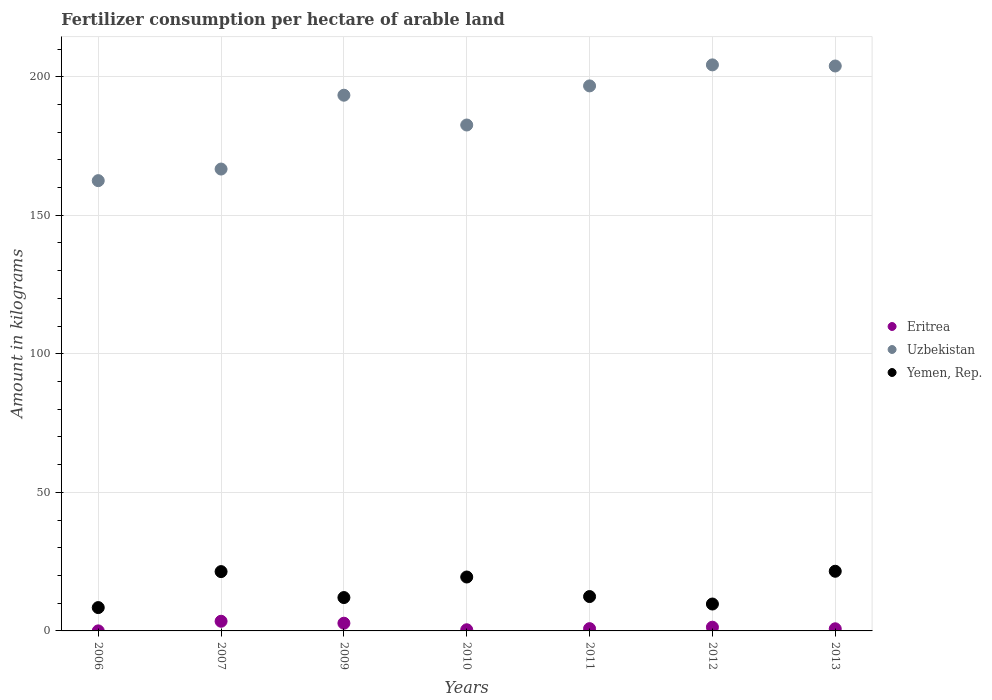Is the number of dotlines equal to the number of legend labels?
Provide a succinct answer. Yes. What is the amount of fertilizer consumption in Yemen, Rep. in 2010?
Keep it short and to the point. 19.46. Across all years, what is the maximum amount of fertilizer consumption in Eritrea?
Keep it short and to the point. 3.49. Across all years, what is the minimum amount of fertilizer consumption in Uzbekistan?
Offer a terse response. 162.5. What is the total amount of fertilizer consumption in Yemen, Rep. in the graph?
Ensure brevity in your answer.  104.98. What is the difference between the amount of fertilizer consumption in Yemen, Rep. in 2009 and that in 2010?
Keep it short and to the point. -7.42. What is the difference between the amount of fertilizer consumption in Uzbekistan in 2012 and the amount of fertilizer consumption in Yemen, Rep. in 2010?
Offer a terse response. 184.82. What is the average amount of fertilizer consumption in Yemen, Rep. per year?
Make the answer very short. 15. In the year 2007, what is the difference between the amount of fertilizer consumption in Eritrea and amount of fertilizer consumption in Uzbekistan?
Your answer should be very brief. -163.2. What is the ratio of the amount of fertilizer consumption in Eritrea in 2009 to that in 2013?
Your answer should be compact. 3.62. Is the amount of fertilizer consumption in Uzbekistan in 2009 less than that in 2012?
Ensure brevity in your answer.  Yes. What is the difference between the highest and the second highest amount of fertilizer consumption in Yemen, Rep.?
Provide a short and direct response. 0.13. What is the difference between the highest and the lowest amount of fertilizer consumption in Uzbekistan?
Provide a succinct answer. 41.78. Is the sum of the amount of fertilizer consumption in Yemen, Rep. in 2009 and 2012 greater than the maximum amount of fertilizer consumption in Eritrea across all years?
Ensure brevity in your answer.  Yes. Is it the case that in every year, the sum of the amount of fertilizer consumption in Uzbekistan and amount of fertilizer consumption in Eritrea  is greater than the amount of fertilizer consumption in Yemen, Rep.?
Offer a very short reply. Yes. How many dotlines are there?
Provide a succinct answer. 3. How many years are there in the graph?
Ensure brevity in your answer.  7. Does the graph contain grids?
Offer a very short reply. Yes. Where does the legend appear in the graph?
Your response must be concise. Center right. How many legend labels are there?
Offer a very short reply. 3. What is the title of the graph?
Offer a terse response. Fertilizer consumption per hectare of arable land. What is the label or title of the X-axis?
Your response must be concise. Years. What is the label or title of the Y-axis?
Provide a succinct answer. Amount in kilograms. What is the Amount in kilograms in Eritrea in 2006?
Make the answer very short. 0.02. What is the Amount in kilograms in Uzbekistan in 2006?
Keep it short and to the point. 162.5. What is the Amount in kilograms in Yemen, Rep. in 2006?
Your answer should be compact. 8.42. What is the Amount in kilograms in Eritrea in 2007?
Ensure brevity in your answer.  3.49. What is the Amount in kilograms in Uzbekistan in 2007?
Offer a terse response. 166.69. What is the Amount in kilograms of Yemen, Rep. in 2007?
Your answer should be very brief. 21.41. What is the Amount in kilograms of Eritrea in 2009?
Your response must be concise. 2.78. What is the Amount in kilograms in Uzbekistan in 2009?
Offer a very short reply. 193.34. What is the Amount in kilograms of Yemen, Rep. in 2009?
Offer a very short reply. 12.04. What is the Amount in kilograms in Eritrea in 2010?
Keep it short and to the point. 0.42. What is the Amount in kilograms in Uzbekistan in 2010?
Ensure brevity in your answer.  182.58. What is the Amount in kilograms in Yemen, Rep. in 2010?
Your answer should be very brief. 19.46. What is the Amount in kilograms in Eritrea in 2011?
Provide a succinct answer. 0.82. What is the Amount in kilograms of Uzbekistan in 2011?
Provide a short and direct response. 196.7. What is the Amount in kilograms in Yemen, Rep. in 2011?
Offer a terse response. 12.4. What is the Amount in kilograms of Eritrea in 2012?
Offer a terse response. 1.34. What is the Amount in kilograms in Uzbekistan in 2012?
Offer a terse response. 204.28. What is the Amount in kilograms of Yemen, Rep. in 2012?
Your answer should be very brief. 9.71. What is the Amount in kilograms of Eritrea in 2013?
Keep it short and to the point. 0.77. What is the Amount in kilograms of Uzbekistan in 2013?
Keep it short and to the point. 203.88. What is the Amount in kilograms in Yemen, Rep. in 2013?
Keep it short and to the point. 21.53. Across all years, what is the maximum Amount in kilograms in Eritrea?
Give a very brief answer. 3.49. Across all years, what is the maximum Amount in kilograms in Uzbekistan?
Your answer should be very brief. 204.28. Across all years, what is the maximum Amount in kilograms in Yemen, Rep.?
Give a very brief answer. 21.53. Across all years, what is the minimum Amount in kilograms in Eritrea?
Your answer should be very brief. 0.02. Across all years, what is the minimum Amount in kilograms in Uzbekistan?
Ensure brevity in your answer.  162.5. Across all years, what is the minimum Amount in kilograms in Yemen, Rep.?
Your answer should be very brief. 8.42. What is the total Amount in kilograms of Eritrea in the graph?
Offer a very short reply. 9.64. What is the total Amount in kilograms in Uzbekistan in the graph?
Offer a very short reply. 1309.96. What is the total Amount in kilograms in Yemen, Rep. in the graph?
Offer a very short reply. 104.98. What is the difference between the Amount in kilograms of Eritrea in 2006 and that in 2007?
Offer a very short reply. -3.47. What is the difference between the Amount in kilograms of Uzbekistan in 2006 and that in 2007?
Ensure brevity in your answer.  -4.19. What is the difference between the Amount in kilograms of Yemen, Rep. in 2006 and that in 2007?
Make the answer very short. -12.98. What is the difference between the Amount in kilograms in Eritrea in 2006 and that in 2009?
Provide a succinct answer. -2.77. What is the difference between the Amount in kilograms in Uzbekistan in 2006 and that in 2009?
Offer a very short reply. -30.84. What is the difference between the Amount in kilograms of Yemen, Rep. in 2006 and that in 2009?
Make the answer very short. -3.62. What is the difference between the Amount in kilograms in Eritrea in 2006 and that in 2010?
Provide a succinct answer. -0.4. What is the difference between the Amount in kilograms in Uzbekistan in 2006 and that in 2010?
Provide a short and direct response. -20.08. What is the difference between the Amount in kilograms in Yemen, Rep. in 2006 and that in 2010?
Your response must be concise. -11.03. What is the difference between the Amount in kilograms in Eritrea in 2006 and that in 2011?
Offer a terse response. -0.81. What is the difference between the Amount in kilograms in Uzbekistan in 2006 and that in 2011?
Ensure brevity in your answer.  -34.2. What is the difference between the Amount in kilograms of Yemen, Rep. in 2006 and that in 2011?
Provide a short and direct response. -3.98. What is the difference between the Amount in kilograms of Eritrea in 2006 and that in 2012?
Provide a short and direct response. -1.33. What is the difference between the Amount in kilograms in Uzbekistan in 2006 and that in 2012?
Give a very brief answer. -41.78. What is the difference between the Amount in kilograms in Yemen, Rep. in 2006 and that in 2012?
Ensure brevity in your answer.  -1.29. What is the difference between the Amount in kilograms in Eritrea in 2006 and that in 2013?
Keep it short and to the point. -0.75. What is the difference between the Amount in kilograms in Uzbekistan in 2006 and that in 2013?
Offer a very short reply. -41.38. What is the difference between the Amount in kilograms in Yemen, Rep. in 2006 and that in 2013?
Provide a short and direct response. -13.11. What is the difference between the Amount in kilograms in Eritrea in 2007 and that in 2009?
Your response must be concise. 0.71. What is the difference between the Amount in kilograms of Uzbekistan in 2007 and that in 2009?
Your answer should be very brief. -26.65. What is the difference between the Amount in kilograms in Yemen, Rep. in 2007 and that in 2009?
Provide a short and direct response. 9.37. What is the difference between the Amount in kilograms of Eritrea in 2007 and that in 2010?
Keep it short and to the point. 3.07. What is the difference between the Amount in kilograms of Uzbekistan in 2007 and that in 2010?
Provide a succinct answer. -15.89. What is the difference between the Amount in kilograms in Yemen, Rep. in 2007 and that in 2010?
Ensure brevity in your answer.  1.95. What is the difference between the Amount in kilograms in Eritrea in 2007 and that in 2011?
Offer a terse response. 2.67. What is the difference between the Amount in kilograms of Uzbekistan in 2007 and that in 2011?
Provide a succinct answer. -30.01. What is the difference between the Amount in kilograms in Yemen, Rep. in 2007 and that in 2011?
Give a very brief answer. 9. What is the difference between the Amount in kilograms of Eritrea in 2007 and that in 2012?
Your answer should be very brief. 2.15. What is the difference between the Amount in kilograms of Uzbekistan in 2007 and that in 2012?
Your answer should be very brief. -37.6. What is the difference between the Amount in kilograms in Yemen, Rep. in 2007 and that in 2012?
Provide a short and direct response. 11.7. What is the difference between the Amount in kilograms of Eritrea in 2007 and that in 2013?
Keep it short and to the point. 2.72. What is the difference between the Amount in kilograms of Uzbekistan in 2007 and that in 2013?
Make the answer very short. -37.2. What is the difference between the Amount in kilograms of Yemen, Rep. in 2007 and that in 2013?
Provide a succinct answer. -0.13. What is the difference between the Amount in kilograms in Eritrea in 2009 and that in 2010?
Provide a short and direct response. 2.37. What is the difference between the Amount in kilograms in Uzbekistan in 2009 and that in 2010?
Offer a very short reply. 10.75. What is the difference between the Amount in kilograms in Yemen, Rep. in 2009 and that in 2010?
Provide a succinct answer. -7.42. What is the difference between the Amount in kilograms in Eritrea in 2009 and that in 2011?
Offer a terse response. 1.96. What is the difference between the Amount in kilograms in Uzbekistan in 2009 and that in 2011?
Keep it short and to the point. -3.36. What is the difference between the Amount in kilograms in Yemen, Rep. in 2009 and that in 2011?
Offer a terse response. -0.36. What is the difference between the Amount in kilograms of Eritrea in 2009 and that in 2012?
Your response must be concise. 1.44. What is the difference between the Amount in kilograms in Uzbekistan in 2009 and that in 2012?
Your answer should be very brief. -10.95. What is the difference between the Amount in kilograms of Yemen, Rep. in 2009 and that in 2012?
Your answer should be compact. 2.33. What is the difference between the Amount in kilograms in Eritrea in 2009 and that in 2013?
Provide a short and direct response. 2.01. What is the difference between the Amount in kilograms in Uzbekistan in 2009 and that in 2013?
Your answer should be compact. -10.55. What is the difference between the Amount in kilograms in Yemen, Rep. in 2009 and that in 2013?
Ensure brevity in your answer.  -9.49. What is the difference between the Amount in kilograms in Eritrea in 2010 and that in 2011?
Keep it short and to the point. -0.4. What is the difference between the Amount in kilograms of Uzbekistan in 2010 and that in 2011?
Ensure brevity in your answer.  -14.11. What is the difference between the Amount in kilograms in Yemen, Rep. in 2010 and that in 2011?
Offer a very short reply. 7.05. What is the difference between the Amount in kilograms of Eritrea in 2010 and that in 2012?
Your response must be concise. -0.93. What is the difference between the Amount in kilograms of Uzbekistan in 2010 and that in 2012?
Your answer should be compact. -21.7. What is the difference between the Amount in kilograms of Yemen, Rep. in 2010 and that in 2012?
Offer a terse response. 9.75. What is the difference between the Amount in kilograms of Eritrea in 2010 and that in 2013?
Offer a very short reply. -0.35. What is the difference between the Amount in kilograms of Uzbekistan in 2010 and that in 2013?
Keep it short and to the point. -21.3. What is the difference between the Amount in kilograms of Yemen, Rep. in 2010 and that in 2013?
Keep it short and to the point. -2.08. What is the difference between the Amount in kilograms of Eritrea in 2011 and that in 2012?
Provide a short and direct response. -0.52. What is the difference between the Amount in kilograms of Uzbekistan in 2011 and that in 2012?
Ensure brevity in your answer.  -7.59. What is the difference between the Amount in kilograms of Yemen, Rep. in 2011 and that in 2012?
Provide a succinct answer. 2.69. What is the difference between the Amount in kilograms in Eritrea in 2011 and that in 2013?
Provide a succinct answer. 0.05. What is the difference between the Amount in kilograms in Uzbekistan in 2011 and that in 2013?
Offer a terse response. -7.19. What is the difference between the Amount in kilograms of Yemen, Rep. in 2011 and that in 2013?
Offer a terse response. -9.13. What is the difference between the Amount in kilograms in Eritrea in 2012 and that in 2013?
Ensure brevity in your answer.  0.57. What is the difference between the Amount in kilograms in Uzbekistan in 2012 and that in 2013?
Ensure brevity in your answer.  0.4. What is the difference between the Amount in kilograms of Yemen, Rep. in 2012 and that in 2013?
Offer a terse response. -11.82. What is the difference between the Amount in kilograms of Eritrea in 2006 and the Amount in kilograms of Uzbekistan in 2007?
Ensure brevity in your answer.  -166.67. What is the difference between the Amount in kilograms in Eritrea in 2006 and the Amount in kilograms in Yemen, Rep. in 2007?
Offer a terse response. -21.39. What is the difference between the Amount in kilograms in Uzbekistan in 2006 and the Amount in kilograms in Yemen, Rep. in 2007?
Provide a succinct answer. 141.09. What is the difference between the Amount in kilograms of Eritrea in 2006 and the Amount in kilograms of Uzbekistan in 2009?
Provide a short and direct response. -193.32. What is the difference between the Amount in kilograms in Eritrea in 2006 and the Amount in kilograms in Yemen, Rep. in 2009?
Offer a terse response. -12.02. What is the difference between the Amount in kilograms in Uzbekistan in 2006 and the Amount in kilograms in Yemen, Rep. in 2009?
Offer a terse response. 150.46. What is the difference between the Amount in kilograms in Eritrea in 2006 and the Amount in kilograms in Uzbekistan in 2010?
Give a very brief answer. -182.56. What is the difference between the Amount in kilograms of Eritrea in 2006 and the Amount in kilograms of Yemen, Rep. in 2010?
Ensure brevity in your answer.  -19.44. What is the difference between the Amount in kilograms of Uzbekistan in 2006 and the Amount in kilograms of Yemen, Rep. in 2010?
Make the answer very short. 143.04. What is the difference between the Amount in kilograms of Eritrea in 2006 and the Amount in kilograms of Uzbekistan in 2011?
Give a very brief answer. -196.68. What is the difference between the Amount in kilograms of Eritrea in 2006 and the Amount in kilograms of Yemen, Rep. in 2011?
Offer a very short reply. -12.39. What is the difference between the Amount in kilograms in Uzbekistan in 2006 and the Amount in kilograms in Yemen, Rep. in 2011?
Your answer should be compact. 150.1. What is the difference between the Amount in kilograms in Eritrea in 2006 and the Amount in kilograms in Uzbekistan in 2012?
Give a very brief answer. -204.27. What is the difference between the Amount in kilograms of Eritrea in 2006 and the Amount in kilograms of Yemen, Rep. in 2012?
Your response must be concise. -9.69. What is the difference between the Amount in kilograms in Uzbekistan in 2006 and the Amount in kilograms in Yemen, Rep. in 2012?
Keep it short and to the point. 152.79. What is the difference between the Amount in kilograms in Eritrea in 2006 and the Amount in kilograms in Uzbekistan in 2013?
Provide a short and direct response. -203.87. What is the difference between the Amount in kilograms in Eritrea in 2006 and the Amount in kilograms in Yemen, Rep. in 2013?
Keep it short and to the point. -21.52. What is the difference between the Amount in kilograms of Uzbekistan in 2006 and the Amount in kilograms of Yemen, Rep. in 2013?
Keep it short and to the point. 140.97. What is the difference between the Amount in kilograms of Eritrea in 2007 and the Amount in kilograms of Uzbekistan in 2009?
Your answer should be compact. -189.85. What is the difference between the Amount in kilograms in Eritrea in 2007 and the Amount in kilograms in Yemen, Rep. in 2009?
Ensure brevity in your answer.  -8.55. What is the difference between the Amount in kilograms in Uzbekistan in 2007 and the Amount in kilograms in Yemen, Rep. in 2009?
Ensure brevity in your answer.  154.65. What is the difference between the Amount in kilograms in Eritrea in 2007 and the Amount in kilograms in Uzbekistan in 2010?
Provide a succinct answer. -179.09. What is the difference between the Amount in kilograms of Eritrea in 2007 and the Amount in kilograms of Yemen, Rep. in 2010?
Your answer should be compact. -15.97. What is the difference between the Amount in kilograms of Uzbekistan in 2007 and the Amount in kilograms of Yemen, Rep. in 2010?
Provide a succinct answer. 147.23. What is the difference between the Amount in kilograms in Eritrea in 2007 and the Amount in kilograms in Uzbekistan in 2011?
Your response must be concise. -193.21. What is the difference between the Amount in kilograms in Eritrea in 2007 and the Amount in kilograms in Yemen, Rep. in 2011?
Provide a short and direct response. -8.91. What is the difference between the Amount in kilograms in Uzbekistan in 2007 and the Amount in kilograms in Yemen, Rep. in 2011?
Provide a succinct answer. 154.28. What is the difference between the Amount in kilograms of Eritrea in 2007 and the Amount in kilograms of Uzbekistan in 2012?
Make the answer very short. -200.79. What is the difference between the Amount in kilograms of Eritrea in 2007 and the Amount in kilograms of Yemen, Rep. in 2012?
Ensure brevity in your answer.  -6.22. What is the difference between the Amount in kilograms of Uzbekistan in 2007 and the Amount in kilograms of Yemen, Rep. in 2012?
Give a very brief answer. 156.98. What is the difference between the Amount in kilograms in Eritrea in 2007 and the Amount in kilograms in Uzbekistan in 2013?
Offer a very short reply. -200.39. What is the difference between the Amount in kilograms of Eritrea in 2007 and the Amount in kilograms of Yemen, Rep. in 2013?
Your answer should be very brief. -18.04. What is the difference between the Amount in kilograms in Uzbekistan in 2007 and the Amount in kilograms in Yemen, Rep. in 2013?
Provide a succinct answer. 145.15. What is the difference between the Amount in kilograms of Eritrea in 2009 and the Amount in kilograms of Uzbekistan in 2010?
Provide a succinct answer. -179.8. What is the difference between the Amount in kilograms of Eritrea in 2009 and the Amount in kilograms of Yemen, Rep. in 2010?
Your answer should be compact. -16.68. What is the difference between the Amount in kilograms of Uzbekistan in 2009 and the Amount in kilograms of Yemen, Rep. in 2010?
Offer a terse response. 173.88. What is the difference between the Amount in kilograms in Eritrea in 2009 and the Amount in kilograms in Uzbekistan in 2011?
Ensure brevity in your answer.  -193.91. What is the difference between the Amount in kilograms in Eritrea in 2009 and the Amount in kilograms in Yemen, Rep. in 2011?
Offer a very short reply. -9.62. What is the difference between the Amount in kilograms of Uzbekistan in 2009 and the Amount in kilograms of Yemen, Rep. in 2011?
Ensure brevity in your answer.  180.93. What is the difference between the Amount in kilograms of Eritrea in 2009 and the Amount in kilograms of Uzbekistan in 2012?
Keep it short and to the point. -201.5. What is the difference between the Amount in kilograms in Eritrea in 2009 and the Amount in kilograms in Yemen, Rep. in 2012?
Provide a short and direct response. -6.93. What is the difference between the Amount in kilograms in Uzbekistan in 2009 and the Amount in kilograms in Yemen, Rep. in 2012?
Make the answer very short. 183.63. What is the difference between the Amount in kilograms in Eritrea in 2009 and the Amount in kilograms in Uzbekistan in 2013?
Give a very brief answer. -201.1. What is the difference between the Amount in kilograms of Eritrea in 2009 and the Amount in kilograms of Yemen, Rep. in 2013?
Ensure brevity in your answer.  -18.75. What is the difference between the Amount in kilograms of Uzbekistan in 2009 and the Amount in kilograms of Yemen, Rep. in 2013?
Keep it short and to the point. 171.8. What is the difference between the Amount in kilograms of Eritrea in 2010 and the Amount in kilograms of Uzbekistan in 2011?
Provide a succinct answer. -196.28. What is the difference between the Amount in kilograms in Eritrea in 2010 and the Amount in kilograms in Yemen, Rep. in 2011?
Provide a short and direct response. -11.99. What is the difference between the Amount in kilograms in Uzbekistan in 2010 and the Amount in kilograms in Yemen, Rep. in 2011?
Provide a succinct answer. 170.18. What is the difference between the Amount in kilograms of Eritrea in 2010 and the Amount in kilograms of Uzbekistan in 2012?
Ensure brevity in your answer.  -203.86. What is the difference between the Amount in kilograms in Eritrea in 2010 and the Amount in kilograms in Yemen, Rep. in 2012?
Offer a very short reply. -9.29. What is the difference between the Amount in kilograms in Uzbekistan in 2010 and the Amount in kilograms in Yemen, Rep. in 2012?
Offer a terse response. 172.87. What is the difference between the Amount in kilograms of Eritrea in 2010 and the Amount in kilograms of Uzbekistan in 2013?
Your answer should be very brief. -203.46. What is the difference between the Amount in kilograms in Eritrea in 2010 and the Amount in kilograms in Yemen, Rep. in 2013?
Offer a very short reply. -21.12. What is the difference between the Amount in kilograms in Uzbekistan in 2010 and the Amount in kilograms in Yemen, Rep. in 2013?
Provide a succinct answer. 161.05. What is the difference between the Amount in kilograms in Eritrea in 2011 and the Amount in kilograms in Uzbekistan in 2012?
Give a very brief answer. -203.46. What is the difference between the Amount in kilograms of Eritrea in 2011 and the Amount in kilograms of Yemen, Rep. in 2012?
Offer a very short reply. -8.89. What is the difference between the Amount in kilograms in Uzbekistan in 2011 and the Amount in kilograms in Yemen, Rep. in 2012?
Keep it short and to the point. 186.99. What is the difference between the Amount in kilograms of Eritrea in 2011 and the Amount in kilograms of Uzbekistan in 2013?
Provide a succinct answer. -203.06. What is the difference between the Amount in kilograms in Eritrea in 2011 and the Amount in kilograms in Yemen, Rep. in 2013?
Offer a very short reply. -20.71. What is the difference between the Amount in kilograms in Uzbekistan in 2011 and the Amount in kilograms in Yemen, Rep. in 2013?
Your response must be concise. 175.16. What is the difference between the Amount in kilograms of Eritrea in 2012 and the Amount in kilograms of Uzbekistan in 2013?
Give a very brief answer. -202.54. What is the difference between the Amount in kilograms in Eritrea in 2012 and the Amount in kilograms in Yemen, Rep. in 2013?
Offer a very short reply. -20.19. What is the difference between the Amount in kilograms of Uzbekistan in 2012 and the Amount in kilograms of Yemen, Rep. in 2013?
Offer a very short reply. 182.75. What is the average Amount in kilograms of Eritrea per year?
Make the answer very short. 1.38. What is the average Amount in kilograms in Uzbekistan per year?
Keep it short and to the point. 187.14. What is the average Amount in kilograms of Yemen, Rep. per year?
Make the answer very short. 15. In the year 2006, what is the difference between the Amount in kilograms of Eritrea and Amount in kilograms of Uzbekistan?
Provide a short and direct response. -162.48. In the year 2006, what is the difference between the Amount in kilograms of Eritrea and Amount in kilograms of Yemen, Rep.?
Your answer should be compact. -8.41. In the year 2006, what is the difference between the Amount in kilograms in Uzbekistan and Amount in kilograms in Yemen, Rep.?
Provide a succinct answer. 154.08. In the year 2007, what is the difference between the Amount in kilograms of Eritrea and Amount in kilograms of Uzbekistan?
Offer a terse response. -163.2. In the year 2007, what is the difference between the Amount in kilograms of Eritrea and Amount in kilograms of Yemen, Rep.?
Give a very brief answer. -17.92. In the year 2007, what is the difference between the Amount in kilograms of Uzbekistan and Amount in kilograms of Yemen, Rep.?
Provide a succinct answer. 145.28. In the year 2009, what is the difference between the Amount in kilograms in Eritrea and Amount in kilograms in Uzbekistan?
Keep it short and to the point. -190.55. In the year 2009, what is the difference between the Amount in kilograms in Eritrea and Amount in kilograms in Yemen, Rep.?
Give a very brief answer. -9.26. In the year 2009, what is the difference between the Amount in kilograms of Uzbekistan and Amount in kilograms of Yemen, Rep.?
Provide a short and direct response. 181.29. In the year 2010, what is the difference between the Amount in kilograms of Eritrea and Amount in kilograms of Uzbekistan?
Offer a very short reply. -182.16. In the year 2010, what is the difference between the Amount in kilograms in Eritrea and Amount in kilograms in Yemen, Rep.?
Offer a very short reply. -19.04. In the year 2010, what is the difference between the Amount in kilograms of Uzbekistan and Amount in kilograms of Yemen, Rep.?
Your answer should be compact. 163.12. In the year 2011, what is the difference between the Amount in kilograms in Eritrea and Amount in kilograms in Uzbekistan?
Give a very brief answer. -195.87. In the year 2011, what is the difference between the Amount in kilograms of Eritrea and Amount in kilograms of Yemen, Rep.?
Your response must be concise. -11.58. In the year 2011, what is the difference between the Amount in kilograms of Uzbekistan and Amount in kilograms of Yemen, Rep.?
Your answer should be very brief. 184.29. In the year 2012, what is the difference between the Amount in kilograms of Eritrea and Amount in kilograms of Uzbekistan?
Your response must be concise. -202.94. In the year 2012, what is the difference between the Amount in kilograms in Eritrea and Amount in kilograms in Yemen, Rep.?
Offer a very short reply. -8.37. In the year 2012, what is the difference between the Amount in kilograms in Uzbekistan and Amount in kilograms in Yemen, Rep.?
Provide a succinct answer. 194.57. In the year 2013, what is the difference between the Amount in kilograms in Eritrea and Amount in kilograms in Uzbekistan?
Offer a very short reply. -203.11. In the year 2013, what is the difference between the Amount in kilograms in Eritrea and Amount in kilograms in Yemen, Rep.?
Provide a succinct answer. -20.76. In the year 2013, what is the difference between the Amount in kilograms of Uzbekistan and Amount in kilograms of Yemen, Rep.?
Ensure brevity in your answer.  182.35. What is the ratio of the Amount in kilograms in Eritrea in 2006 to that in 2007?
Make the answer very short. 0. What is the ratio of the Amount in kilograms of Uzbekistan in 2006 to that in 2007?
Provide a short and direct response. 0.97. What is the ratio of the Amount in kilograms of Yemen, Rep. in 2006 to that in 2007?
Offer a very short reply. 0.39. What is the ratio of the Amount in kilograms in Eritrea in 2006 to that in 2009?
Offer a terse response. 0.01. What is the ratio of the Amount in kilograms in Uzbekistan in 2006 to that in 2009?
Make the answer very short. 0.84. What is the ratio of the Amount in kilograms in Yemen, Rep. in 2006 to that in 2009?
Your answer should be compact. 0.7. What is the ratio of the Amount in kilograms of Eritrea in 2006 to that in 2010?
Offer a terse response. 0.04. What is the ratio of the Amount in kilograms of Uzbekistan in 2006 to that in 2010?
Offer a very short reply. 0.89. What is the ratio of the Amount in kilograms of Yemen, Rep. in 2006 to that in 2010?
Make the answer very short. 0.43. What is the ratio of the Amount in kilograms in Uzbekistan in 2006 to that in 2011?
Offer a very short reply. 0.83. What is the ratio of the Amount in kilograms in Yemen, Rep. in 2006 to that in 2011?
Give a very brief answer. 0.68. What is the ratio of the Amount in kilograms of Eritrea in 2006 to that in 2012?
Offer a terse response. 0.01. What is the ratio of the Amount in kilograms of Uzbekistan in 2006 to that in 2012?
Give a very brief answer. 0.8. What is the ratio of the Amount in kilograms in Yemen, Rep. in 2006 to that in 2012?
Provide a succinct answer. 0.87. What is the ratio of the Amount in kilograms of Eritrea in 2006 to that in 2013?
Give a very brief answer. 0.02. What is the ratio of the Amount in kilograms in Uzbekistan in 2006 to that in 2013?
Your answer should be compact. 0.8. What is the ratio of the Amount in kilograms of Yemen, Rep. in 2006 to that in 2013?
Your answer should be compact. 0.39. What is the ratio of the Amount in kilograms in Eritrea in 2007 to that in 2009?
Your answer should be compact. 1.25. What is the ratio of the Amount in kilograms of Uzbekistan in 2007 to that in 2009?
Provide a succinct answer. 0.86. What is the ratio of the Amount in kilograms of Yemen, Rep. in 2007 to that in 2009?
Offer a very short reply. 1.78. What is the ratio of the Amount in kilograms in Eritrea in 2007 to that in 2010?
Your answer should be very brief. 8.36. What is the ratio of the Amount in kilograms in Uzbekistan in 2007 to that in 2010?
Provide a short and direct response. 0.91. What is the ratio of the Amount in kilograms of Yemen, Rep. in 2007 to that in 2010?
Give a very brief answer. 1.1. What is the ratio of the Amount in kilograms of Eritrea in 2007 to that in 2011?
Keep it short and to the point. 4.25. What is the ratio of the Amount in kilograms of Uzbekistan in 2007 to that in 2011?
Your answer should be compact. 0.85. What is the ratio of the Amount in kilograms of Yemen, Rep. in 2007 to that in 2011?
Offer a very short reply. 1.73. What is the ratio of the Amount in kilograms of Eritrea in 2007 to that in 2012?
Your response must be concise. 2.6. What is the ratio of the Amount in kilograms of Uzbekistan in 2007 to that in 2012?
Ensure brevity in your answer.  0.82. What is the ratio of the Amount in kilograms of Yemen, Rep. in 2007 to that in 2012?
Your answer should be compact. 2.2. What is the ratio of the Amount in kilograms of Eritrea in 2007 to that in 2013?
Provide a short and direct response. 4.53. What is the ratio of the Amount in kilograms of Uzbekistan in 2007 to that in 2013?
Provide a succinct answer. 0.82. What is the ratio of the Amount in kilograms in Yemen, Rep. in 2007 to that in 2013?
Your answer should be very brief. 0.99. What is the ratio of the Amount in kilograms in Eritrea in 2009 to that in 2010?
Give a very brief answer. 6.67. What is the ratio of the Amount in kilograms of Uzbekistan in 2009 to that in 2010?
Offer a terse response. 1.06. What is the ratio of the Amount in kilograms of Yemen, Rep. in 2009 to that in 2010?
Make the answer very short. 0.62. What is the ratio of the Amount in kilograms of Eritrea in 2009 to that in 2011?
Provide a short and direct response. 3.39. What is the ratio of the Amount in kilograms of Uzbekistan in 2009 to that in 2011?
Provide a succinct answer. 0.98. What is the ratio of the Amount in kilograms in Yemen, Rep. in 2009 to that in 2011?
Your response must be concise. 0.97. What is the ratio of the Amount in kilograms of Eritrea in 2009 to that in 2012?
Provide a short and direct response. 2.07. What is the ratio of the Amount in kilograms of Uzbekistan in 2009 to that in 2012?
Your answer should be very brief. 0.95. What is the ratio of the Amount in kilograms of Yemen, Rep. in 2009 to that in 2012?
Provide a short and direct response. 1.24. What is the ratio of the Amount in kilograms of Eritrea in 2009 to that in 2013?
Provide a succinct answer. 3.62. What is the ratio of the Amount in kilograms in Uzbekistan in 2009 to that in 2013?
Provide a short and direct response. 0.95. What is the ratio of the Amount in kilograms of Yemen, Rep. in 2009 to that in 2013?
Ensure brevity in your answer.  0.56. What is the ratio of the Amount in kilograms in Eritrea in 2010 to that in 2011?
Your answer should be compact. 0.51. What is the ratio of the Amount in kilograms of Uzbekistan in 2010 to that in 2011?
Your response must be concise. 0.93. What is the ratio of the Amount in kilograms of Yemen, Rep. in 2010 to that in 2011?
Give a very brief answer. 1.57. What is the ratio of the Amount in kilograms in Eritrea in 2010 to that in 2012?
Ensure brevity in your answer.  0.31. What is the ratio of the Amount in kilograms of Uzbekistan in 2010 to that in 2012?
Your response must be concise. 0.89. What is the ratio of the Amount in kilograms of Yemen, Rep. in 2010 to that in 2012?
Give a very brief answer. 2. What is the ratio of the Amount in kilograms of Eritrea in 2010 to that in 2013?
Your answer should be very brief. 0.54. What is the ratio of the Amount in kilograms of Uzbekistan in 2010 to that in 2013?
Provide a succinct answer. 0.9. What is the ratio of the Amount in kilograms of Yemen, Rep. in 2010 to that in 2013?
Your answer should be very brief. 0.9. What is the ratio of the Amount in kilograms of Eritrea in 2011 to that in 2012?
Offer a terse response. 0.61. What is the ratio of the Amount in kilograms of Uzbekistan in 2011 to that in 2012?
Provide a succinct answer. 0.96. What is the ratio of the Amount in kilograms of Yemen, Rep. in 2011 to that in 2012?
Your response must be concise. 1.28. What is the ratio of the Amount in kilograms in Eritrea in 2011 to that in 2013?
Your answer should be compact. 1.07. What is the ratio of the Amount in kilograms in Uzbekistan in 2011 to that in 2013?
Your answer should be compact. 0.96. What is the ratio of the Amount in kilograms in Yemen, Rep. in 2011 to that in 2013?
Offer a very short reply. 0.58. What is the ratio of the Amount in kilograms in Eritrea in 2012 to that in 2013?
Provide a short and direct response. 1.75. What is the ratio of the Amount in kilograms of Yemen, Rep. in 2012 to that in 2013?
Provide a succinct answer. 0.45. What is the difference between the highest and the second highest Amount in kilograms in Eritrea?
Give a very brief answer. 0.71. What is the difference between the highest and the second highest Amount in kilograms of Uzbekistan?
Your answer should be compact. 0.4. What is the difference between the highest and the second highest Amount in kilograms of Yemen, Rep.?
Offer a very short reply. 0.13. What is the difference between the highest and the lowest Amount in kilograms in Eritrea?
Your answer should be compact. 3.47. What is the difference between the highest and the lowest Amount in kilograms in Uzbekistan?
Make the answer very short. 41.78. What is the difference between the highest and the lowest Amount in kilograms of Yemen, Rep.?
Offer a terse response. 13.11. 